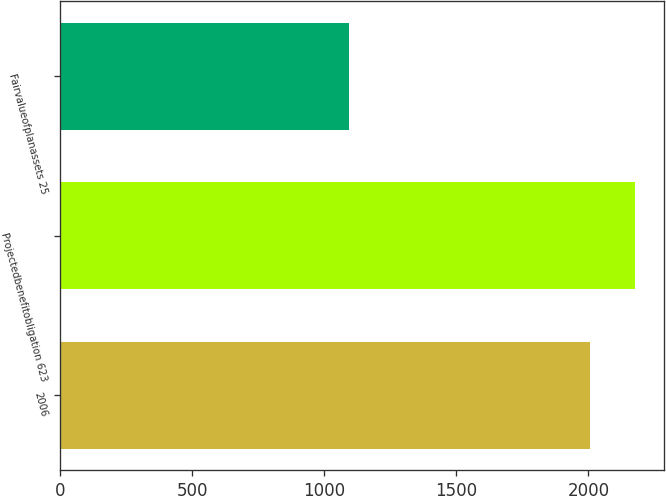Convert chart. <chart><loc_0><loc_0><loc_500><loc_500><bar_chart><fcel>2006<fcel>Projectedbenefitobligation 623<fcel>Fairvalueofplanassets 25<nl><fcel>2005<fcel>2176<fcel>1093<nl></chart> 